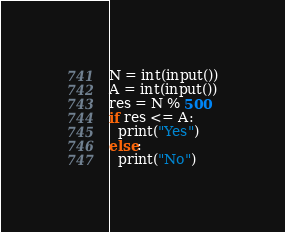<code> <loc_0><loc_0><loc_500><loc_500><_Python_>N = int(input())
A = int(input())
res = N % 500
if res <= A:
  print("Yes")
else:
  print("No")</code> 